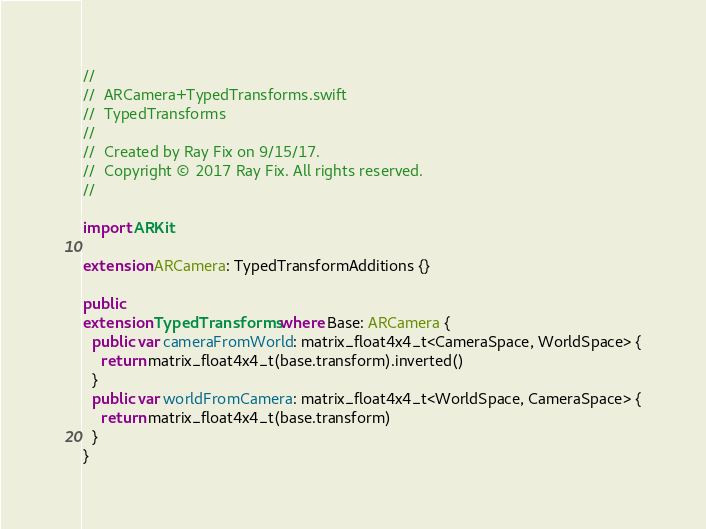<code> <loc_0><loc_0><loc_500><loc_500><_Swift_>//
//  ARCamera+TypedTransforms.swift
//  TypedTransforms
//
//  Created by Ray Fix on 9/15/17.
//  Copyright © 2017 Ray Fix. All rights reserved.
//

import ARKit

extension ARCamera: TypedTransformAdditions {}

public
extension TypedTransforms where Base: ARCamera {
  public var cameraFromWorld: matrix_float4x4_t<CameraSpace, WorldSpace> {
    return matrix_float4x4_t(base.transform).inverted()
  }
  public var worldFromCamera: matrix_float4x4_t<WorldSpace, CameraSpace> {
    return matrix_float4x4_t(base.transform)
  }
}
</code> 